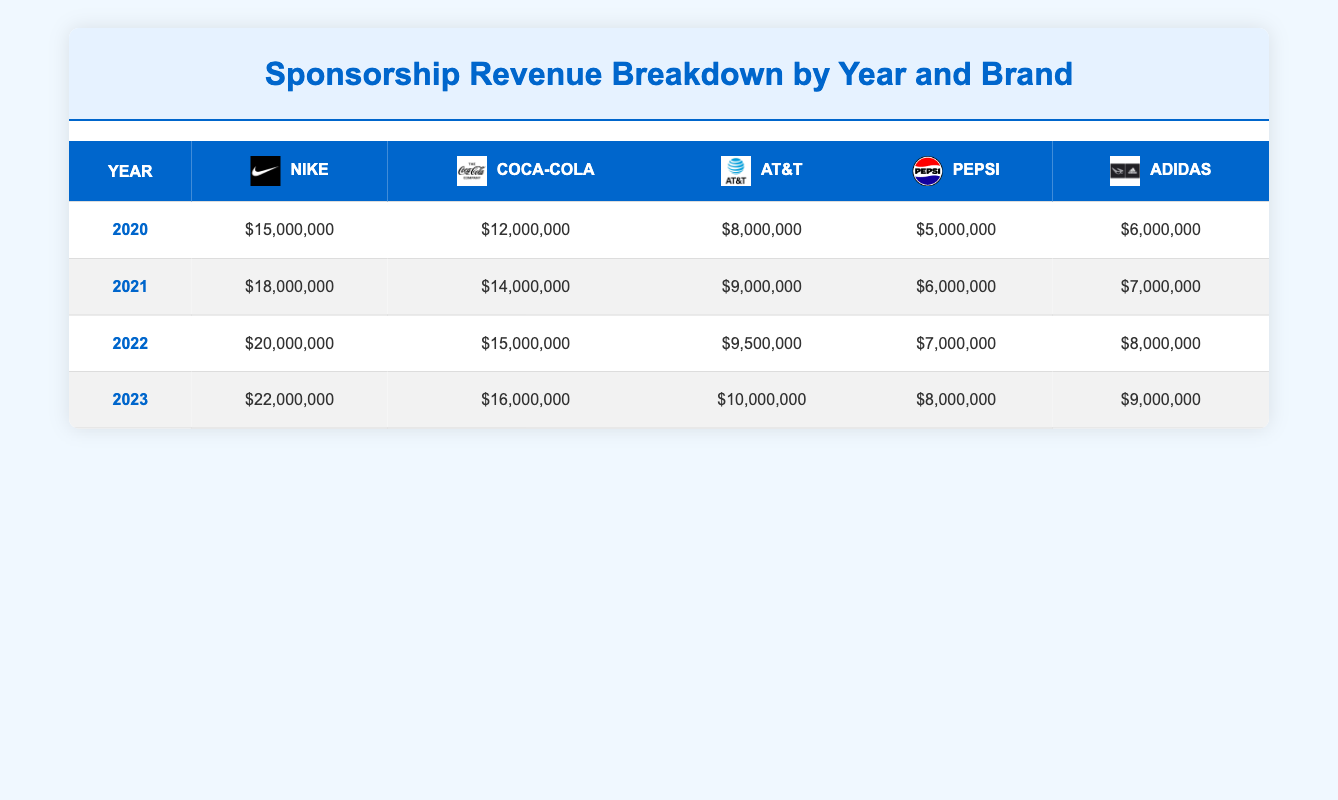What was Nike's sponsorship revenue in 2022? In the table, under the year 2022, the sponsorship revenue for Nike is listed as $20,000,000.
Answer: $20,000,000 Which brand had the highest sponsorship revenue in 2021? If we look at the table for the year 2021, Nike had the highest revenue at $18,000,000.
Answer: Nike What is the total sponsorship revenue for Coca-Cola from 2020 to 2023? To find the total, we add the values: $12,000,000 (2020) + $14,000,000 (2021) + $15,000,000 (2022) + $16,000,000 (2023) = $57,000,000.
Answer: $57,000,000 Did AT&T's sponsorship revenue increase every year from 2020 to 2023? We check the yearly revenues: $8,000,000 (2020), $9,000,000 (2021), $9,500,000 (2022), and $10,000,000 (2023) which shows an increase each year.
Answer: Yes What is the average sponsorship revenue for Pepsi over the four years? We need to calculate the average by summing the values: $5,000,000 (2020) + $6,000,000 (2021) + $7,000,000 (2022) + $8,000,000 (2023) = $26,000,000, then divide by 4, giving us an average of $6,500,000.
Answer: $6,500,000 Which brand saw the largest percentage increase in sponsorship revenue from 2020 to 2023? We calculate the percentage increase: Nike = (22,000,000 - 15,000,000) / 15,000,000 * 100 = 46.67%, Coca-Cola = (16,000,000 - 12,000,000) / 12,000,000 * 100 = 33.33%, and so on. The largest increase is for Nike.
Answer: Nike What was the total sponsorship revenue for Adidas in all four years? We find the total by adding: $6,000,000 (2020) + $7,000,000 (2021) + $8,000,000 (2022) + $9,000,000 (2023) = $30,000,000.
Answer: $30,000,000 What year had the lowest total sponsorship revenue across all brands? We calculate the total for each year: 2020 = $15M + $12M + $8M + $5M + $6M = $46M, 2021 = $18M + $14M + $9M + $6M + $7M = $54M, 2022 = $20M + $15M + $9.5M + $7M + $8M = $59.5M, 2023 = $22M + $16M + $10M + $8M + $9M = $65M, making 2020 the lowest year.
Answer: 2020 What is the difference in sponsorship revenue for Coca-Cola between 2020 and 2023? We find the difference by subtracting the values: $16,000,000 (2023) - $12,000,000 (2020) = $4,000,000.
Answer: $4,000,000 Which year had a total sponsorship revenue of over $50 million? Checking the totals calculated for each year, we find that 2021 ($54,000,000), 2022 ($59,500,000), and 2023 ($65,000,000) all exceed $50 million.
Answer: 2021, 2022, and 2023 